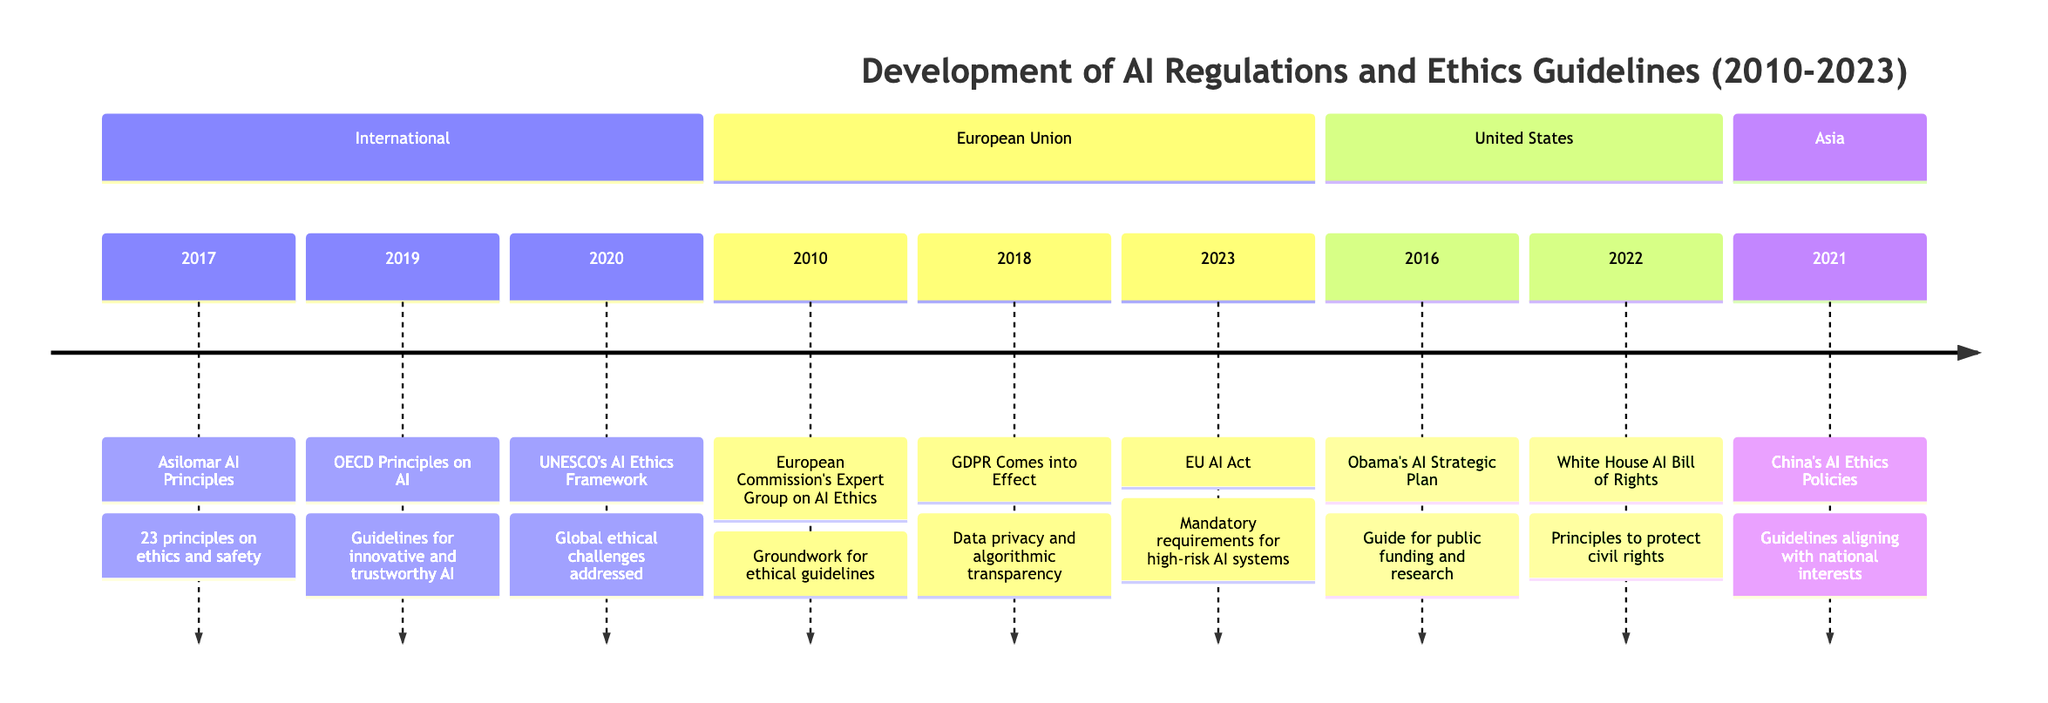What year did the OECD Principles on AI get released? The diagram clearly indicates that the OECD Principles on AI were released in 2019. This is noted in the "International" section under the year 2019.
Answer: 2019 What is the main purpose of the European Commission's Expert Group on AI Ethics? The event in 2010 in the "European Union" section states that the purpose of forming the Expert Group was to lay the groundwork for ethical AI guidelines. This information allows us to summarize the main purpose effectively.
Answer: Groundwork for ethical guidelines How many significant events are listed for Asia in the timeline? By examining the "Asia" section of the timeline, I can see that only one event is listed, which pertains to China's AI Ethics Policies in 2021. Thus, the total count of significant events for Asia is one.
Answer: 1 Which entity published the AI Bill of Rights in 2022? The timeline specifies that the White House published the AI Bill of Rights in the year 2022, which is noted in the "United States" section of the diagram.
Answer: White House What is the relationship between GDPR and AI? According to the timeline, the General Data Protection Regulation (GDPR) came into effect in 2018 and introduced regulations impacting AI, specifically regarding data privacy and algorithmic transparency. This establishes a direct relationship between the two, as GDPR affects how AI systems handle data.
Answer: Data privacy and algorithmic transparency Which guideline emphasizes the importance of civil rights in AI? The diagram notes that the White House AI Bill of Rights published in 2022 emphasizes civil rights protection in the context of AI, indicating its main focus area.
Answer: White House AI Bill of Rights What year marks the expected finalization of the EU AI Act? The timeline specifies that the expected finalization of the EU AI Act is set for 2023, as stated in the "European Union" section under that year.
Answer: 2023 How many organizations contributed to significant AI regulations and ethics guidelines between 2010 and 2023? By reviewing the entities involved in the timeline, we identify four distinct sources: the European Commission, Obama Administration, OECD, and UNESCO among others. Thus, the organizations contributing to significant guidelines total seven if we consider each distinct origin.
Answer: 7 